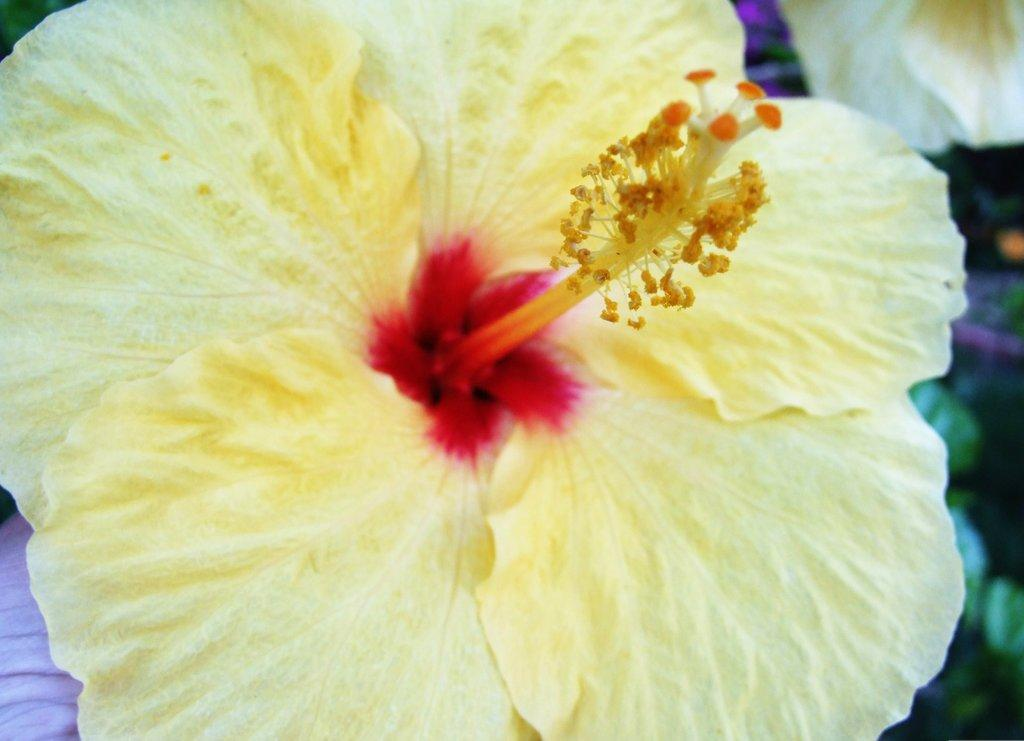What is the main subject of the image? There is a flower in the image. What type of cap is being worn by the grain in the image? There is no grain or cap present in the image; it features a flower. How many hands are visible holding the flower in the image? There are no hands visible in the image, as it only features a flower. 